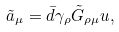Convert formula to latex. <formula><loc_0><loc_0><loc_500><loc_500>\tilde { a } _ { \mu } = \bar { d } \gamma _ { \rho } \tilde { G } _ { \rho \mu } u ,</formula> 